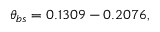Convert formula to latex. <formula><loc_0><loc_0><loc_500><loc_500>\theta _ { b s } = 0 . 1 3 0 9 - 0 . 2 0 7 6 ,</formula> 